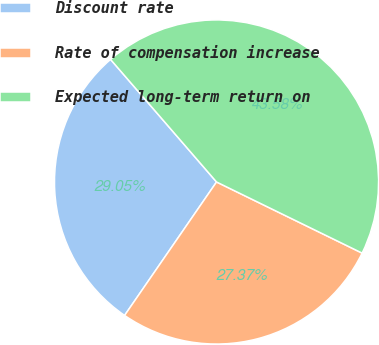Convert chart to OTSL. <chart><loc_0><loc_0><loc_500><loc_500><pie_chart><fcel>Discount rate<fcel>Rate of compensation increase<fcel>Expected long-term return on<nl><fcel>29.05%<fcel>27.37%<fcel>43.58%<nl></chart> 